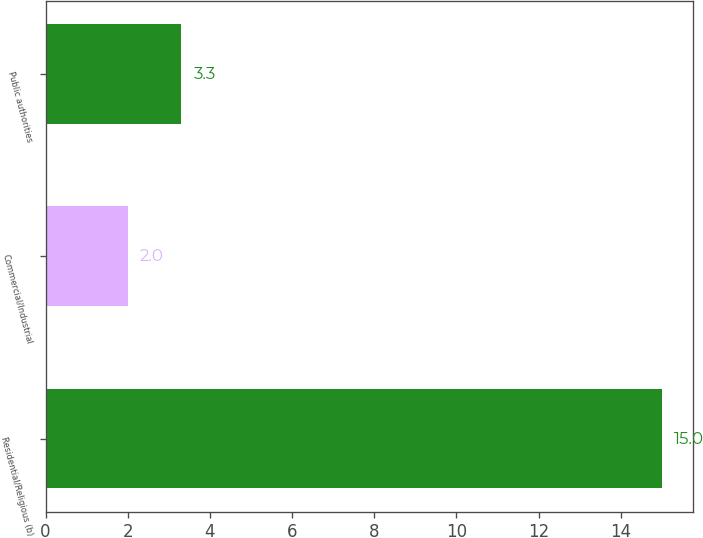Convert chart to OTSL. <chart><loc_0><loc_0><loc_500><loc_500><bar_chart><fcel>Residential/Religious (b)<fcel>Commercial/Industrial<fcel>Public authorities<nl><fcel>15<fcel>2<fcel>3.3<nl></chart> 